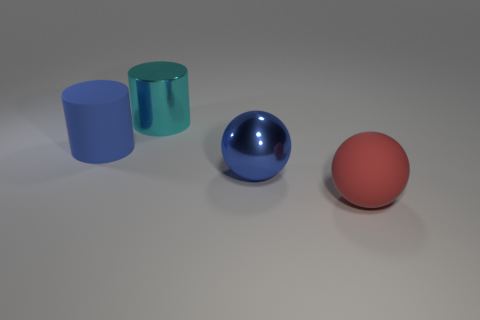Is the number of large metallic balls behind the big cyan object the same as the number of big cyan metal things that are right of the large blue metal thing?
Offer a very short reply. Yes. There is a cyan metal object that is the same size as the red rubber thing; what shape is it?
Offer a very short reply. Cylinder. Are there any large metal cylinders that have the same color as the rubber sphere?
Offer a very short reply. No. What is the shape of the blue thing that is in front of the large matte cylinder?
Your answer should be very brief. Sphere. The shiny sphere has what color?
Give a very brief answer. Blue. The large sphere that is made of the same material as the cyan thing is what color?
Ensure brevity in your answer.  Blue. How many cyan things are the same material as the large red ball?
Your answer should be compact. 0. What number of large shiny balls are to the left of the blue ball?
Provide a succinct answer. 0. Is the cyan object that is behind the big red object made of the same material as the big blue thing that is on the right side of the large metal cylinder?
Give a very brief answer. Yes. Is the number of large red objects that are behind the big rubber sphere greater than the number of big spheres that are right of the rubber cylinder?
Your answer should be very brief. No. 